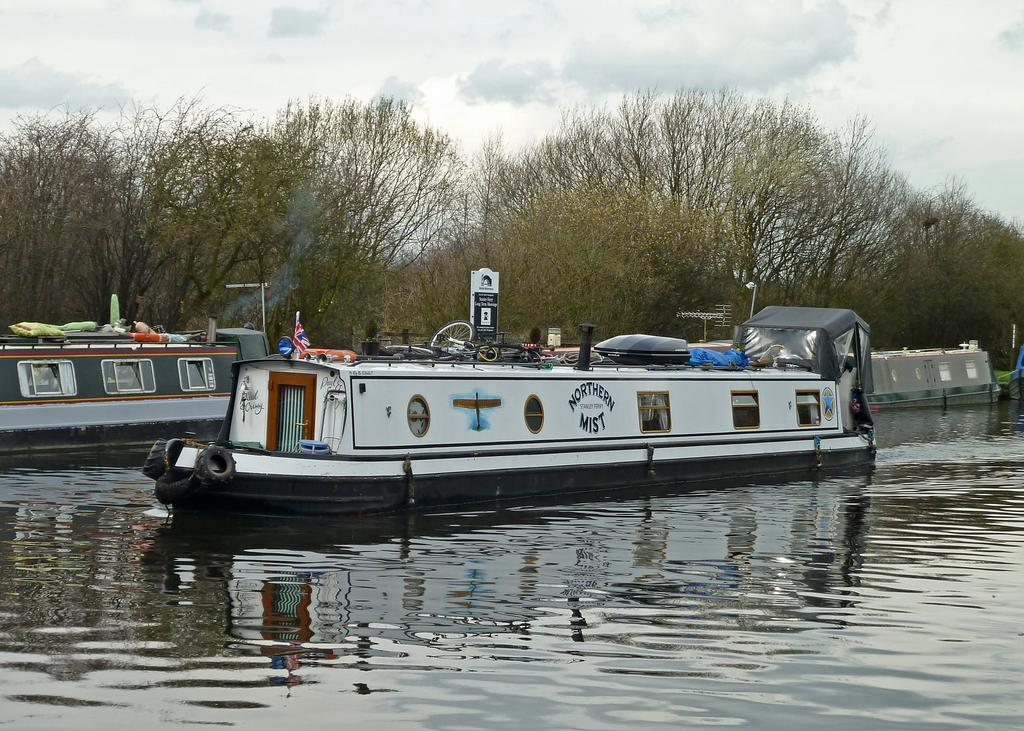What is in the water in the image? There are boats in the water in the image. What type of natural environment can be seen in the image? There are trees visible in the image. What is written or displayed on the board in the image? There is a board with text in the image. How would you describe the weather based on the sky in the image? The sky is cloudy in the image. Can you see anyone cooking or preparing food in the image? There is no indication of cooking or food preparation in the image. Is there any dirt visible in the image? The image does not show any dirt or soil. 